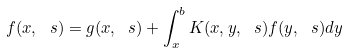Convert formula to latex. <formula><loc_0><loc_0><loc_500><loc_500>f ( x , \ s ) = g ( x , \ s ) + \int _ { x } ^ { b } K ( x , y , \ s ) f ( y , \ s ) d y</formula> 